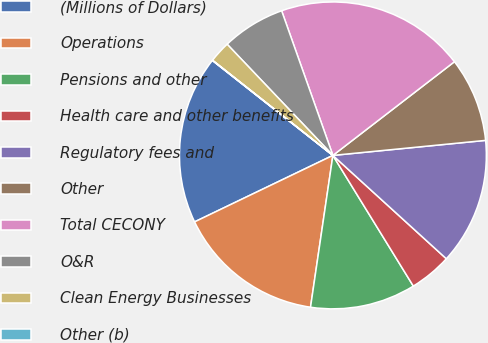<chart> <loc_0><loc_0><loc_500><loc_500><pie_chart><fcel>(Millions of Dollars)<fcel>Operations<fcel>Pensions and other<fcel>Health care and other benefits<fcel>Regulatory fees and<fcel>Other<fcel>Total CECONY<fcel>O&R<fcel>Clean Energy Businesses<fcel>Other (b)<nl><fcel>17.75%<fcel>15.54%<fcel>11.11%<fcel>4.46%<fcel>13.32%<fcel>8.89%<fcel>19.97%<fcel>6.68%<fcel>2.25%<fcel>0.03%<nl></chart> 